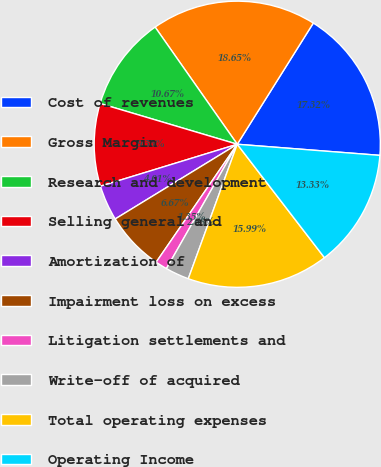<chart> <loc_0><loc_0><loc_500><loc_500><pie_chart><fcel>Cost of revenues<fcel>Gross Margin<fcel>Research and development<fcel>Selling general and<fcel>Amortization of<fcel>Impairment loss on excess<fcel>Litigation settlements and<fcel>Write-off of acquired<fcel>Total operating expenses<fcel>Operating Income<nl><fcel>17.32%<fcel>18.65%<fcel>10.67%<fcel>9.33%<fcel>4.01%<fcel>6.67%<fcel>1.35%<fcel>2.68%<fcel>15.99%<fcel>13.33%<nl></chart> 